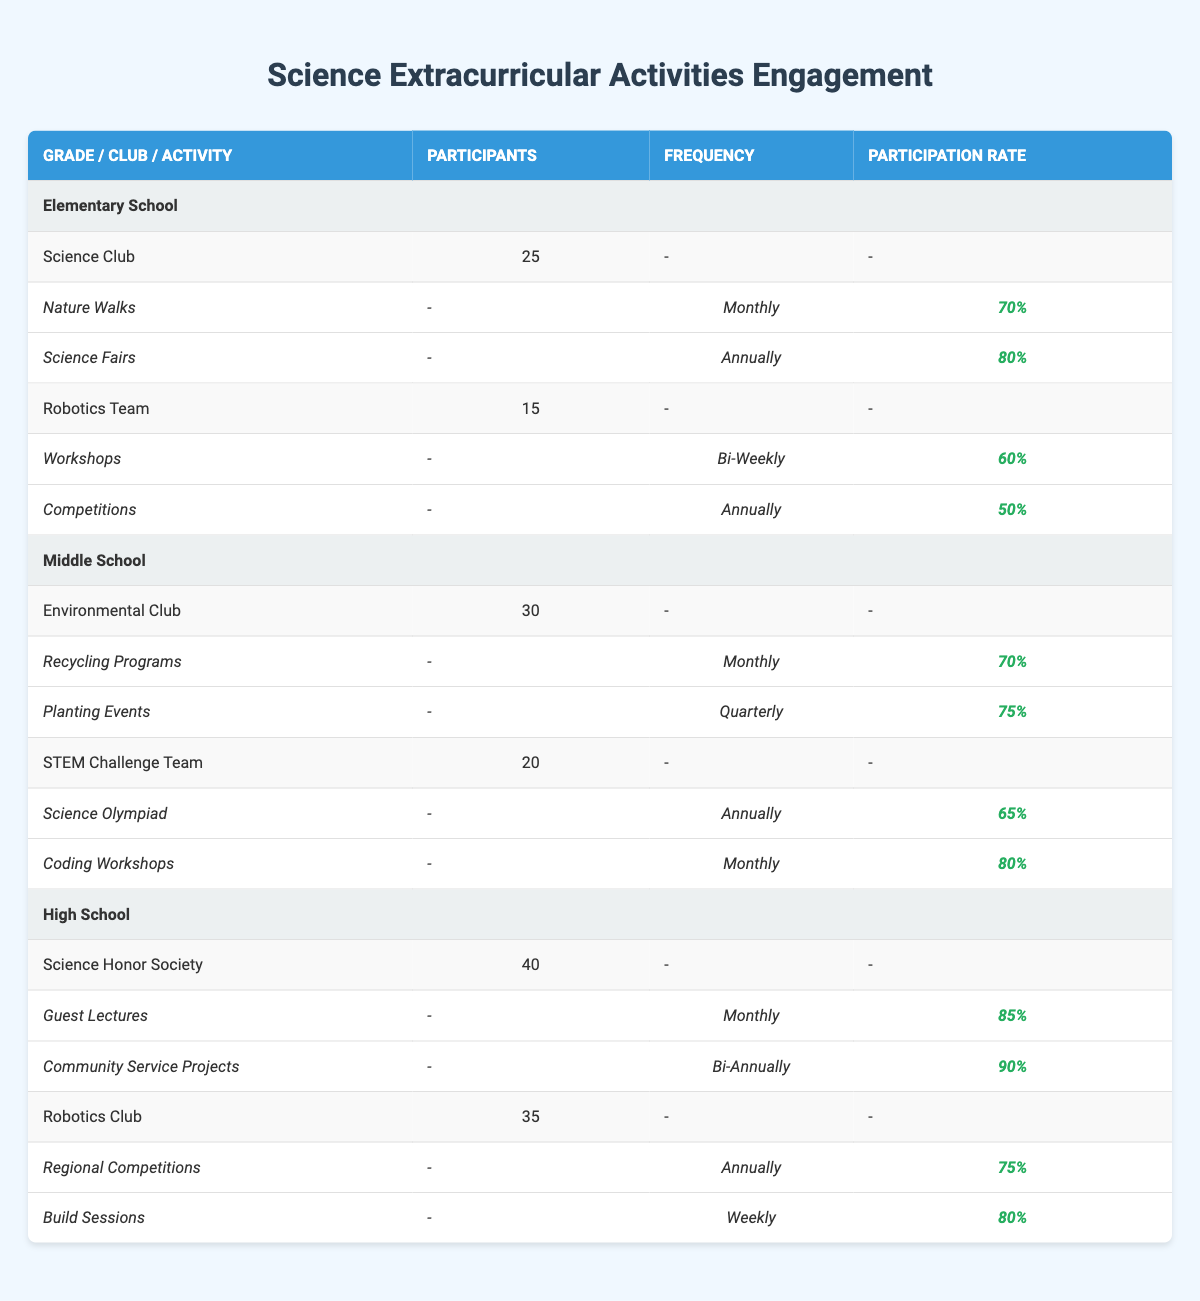What is the participation rate for the Science Fairs in the Elementary School? The participation rate for the Science Fairs is listed under the Science Club activities for Elementary School. It shows a participation rate of 80%.
Answer: 80% How many participants are in the High School Science Honor Society? The number of participants in the Science Honor Society is stated clearly in the table, which shows there are 40 participants.
Answer: 40 Which club in Middle School has the highest participation rate for its activities? The Environmental Club has two activities with participation rates of 70% (Recycling Programs) and 75% (Planting Events). The STEM Challenge Team has rates of 65% (Science Olympiad) and 80% (Coding Workshops). Thus, the highest participation rate is 80% from the Coding Workshops of the STEM Challenge Team.
Answer: STEM Challenge Team What is the overall average participation rate for each grade level across all activities? For Elementary School: (70%+80%+60%+50%)/4 = 65%. For Middle School: (70%+75%+65%+80%)/4 = 72.5%. For High School: (85%+90%+75%+80%)/4 = 82.5%. The average participation rates are: Elementary 65%, Middle 72.5%, High School 82.5%. Overall average = (65%+72.5%+82.5%)/3 = 73.33%.
Answer: 73.33% Does the Robotics Club in High School have more participants than the Science Club in Elementary School? The Robotics Club in High School has 35 participants, while the Science Club in Elementary School has 25 participants. Since 35 is greater than 25, the Robotics Club has more participants.
Answer: Yes What percentage increase in participants does the Science Honor Society have compared to the Robotics Team in High School? The Science Honor Society has 40 participants, while the Robotics Team has 35 participants. The increase in participants is (40-35) = 5. The percentage increase is (5/35)*100 = 14.29%.
Answer: 14.29% 